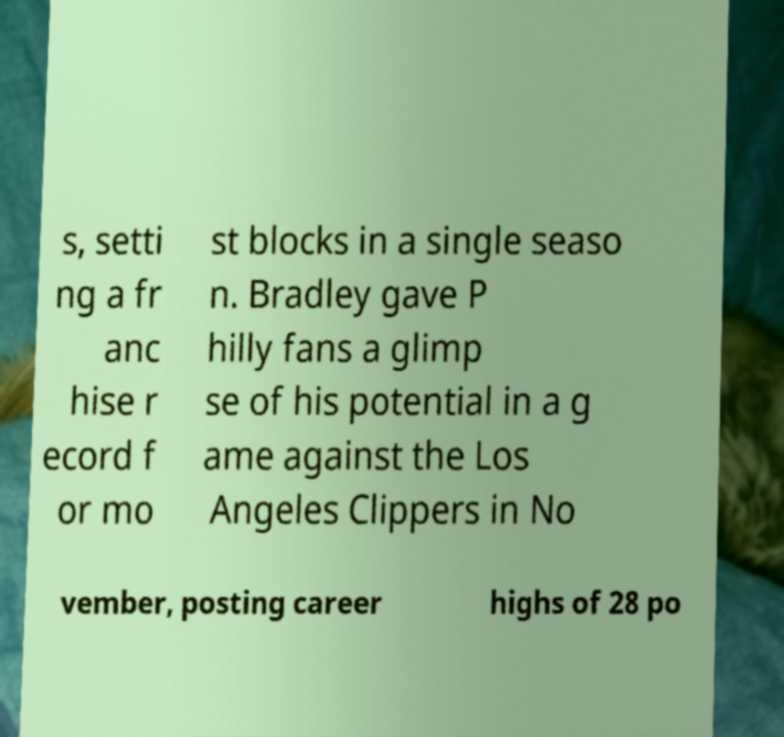Please identify and transcribe the text found in this image. s, setti ng a fr anc hise r ecord f or mo st blocks in a single seaso n. Bradley gave P hilly fans a glimp se of his potential in a g ame against the Los Angeles Clippers in No vember, posting career highs of 28 po 